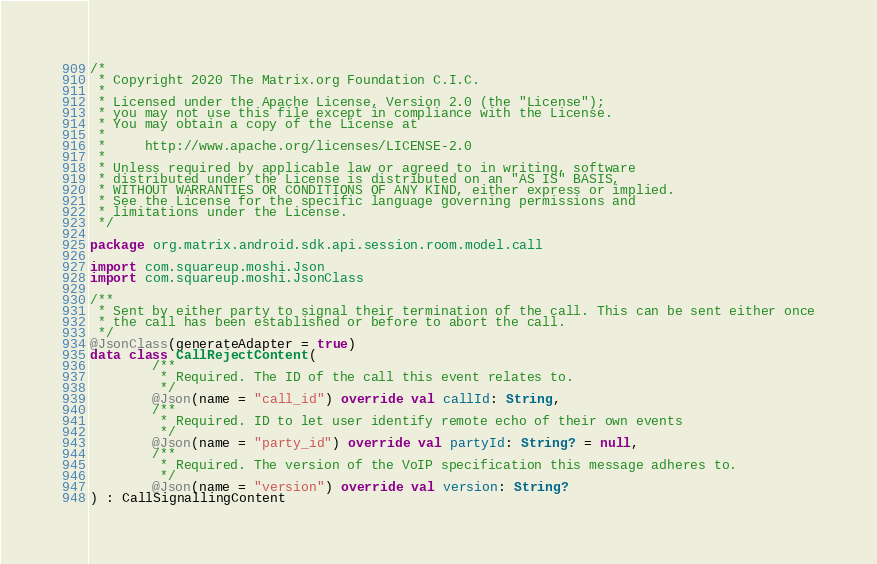Convert code to text. <code><loc_0><loc_0><loc_500><loc_500><_Kotlin_>/*
 * Copyright 2020 The Matrix.org Foundation C.I.C.
 *
 * Licensed under the Apache License, Version 2.0 (the "License");
 * you may not use this file except in compliance with the License.
 * You may obtain a copy of the License at
 *
 *     http://www.apache.org/licenses/LICENSE-2.0
 *
 * Unless required by applicable law or agreed to in writing, software
 * distributed under the License is distributed on an "AS IS" BASIS,
 * WITHOUT WARRANTIES OR CONDITIONS OF ANY KIND, either express or implied.
 * See the License for the specific language governing permissions and
 * limitations under the License.
 */

package org.matrix.android.sdk.api.session.room.model.call

import com.squareup.moshi.Json
import com.squareup.moshi.JsonClass

/**
 * Sent by either party to signal their termination of the call. This can be sent either once
 * the call has been established or before to abort the call.
 */
@JsonClass(generateAdapter = true)
data class CallRejectContent(
        /**
         * Required. The ID of the call this event relates to.
         */
        @Json(name = "call_id") override val callId: String,
        /**
         * Required. ID to let user identify remote echo of their own events
         */
        @Json(name = "party_id") override val partyId: String? = null,
        /**
         * Required. The version of the VoIP specification this message adheres to.
         */
        @Json(name = "version") override val version: String?
) : CallSignallingContent
</code> 